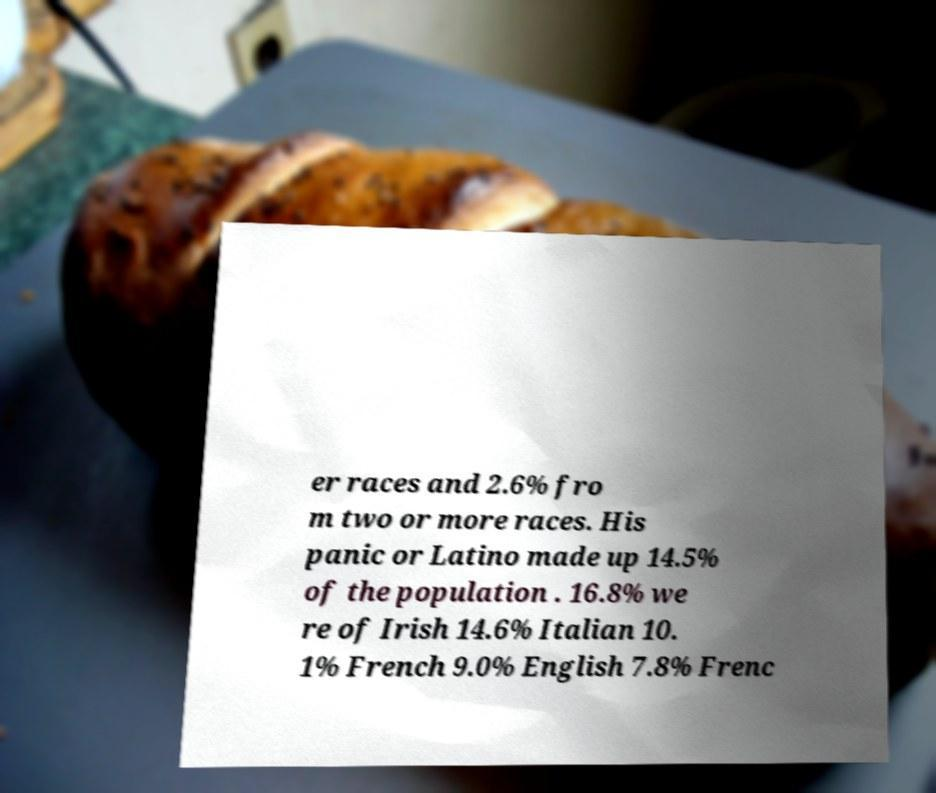Can you accurately transcribe the text from the provided image for me? er races and 2.6% fro m two or more races. His panic or Latino made up 14.5% of the population . 16.8% we re of Irish 14.6% Italian 10. 1% French 9.0% English 7.8% Frenc 